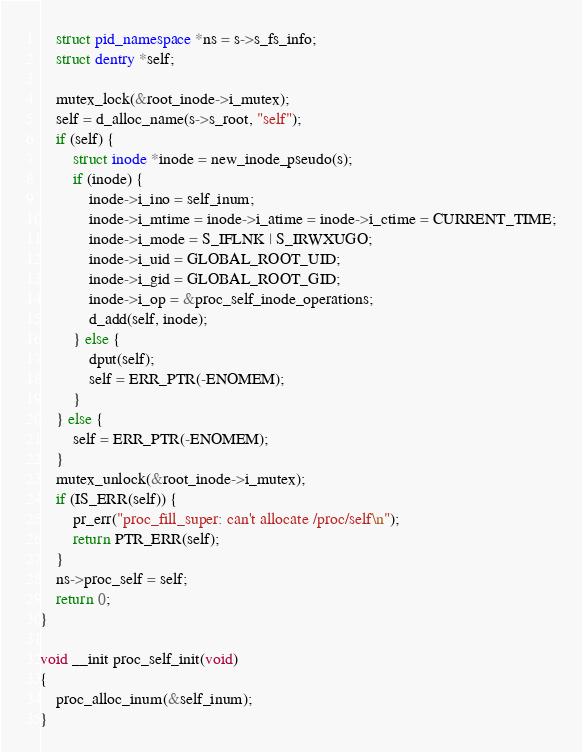<code> <loc_0><loc_0><loc_500><loc_500><_C_>	struct pid_namespace *ns = s->s_fs_info;
	struct dentry *self;
	
	mutex_lock(&root_inode->i_mutex);
	self = d_alloc_name(s->s_root, "self");
	if (self) {
		struct inode *inode = new_inode_pseudo(s);
		if (inode) {
			inode->i_ino = self_inum;
			inode->i_mtime = inode->i_atime = inode->i_ctime = CURRENT_TIME;
			inode->i_mode = S_IFLNK | S_IRWXUGO;
			inode->i_uid = GLOBAL_ROOT_UID;
			inode->i_gid = GLOBAL_ROOT_GID;
			inode->i_op = &proc_self_inode_operations;
			d_add(self, inode);
		} else {
			dput(self);
			self = ERR_PTR(-ENOMEM);
		}
	} else {
		self = ERR_PTR(-ENOMEM);
	}
	mutex_unlock(&root_inode->i_mutex);
	if (IS_ERR(self)) {
		pr_err("proc_fill_super: can't allocate /proc/self\n");
		return PTR_ERR(self);
	}
	ns->proc_self = self;
	return 0;
}

void __init proc_self_init(void)
{
	proc_alloc_inum(&self_inum);
}
</code> 